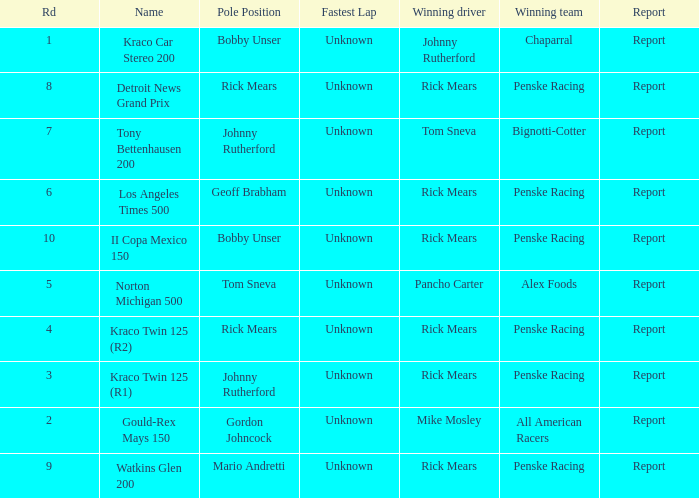How many winning drivers in the kraco twin 125 (r2) race were there? 1.0. 